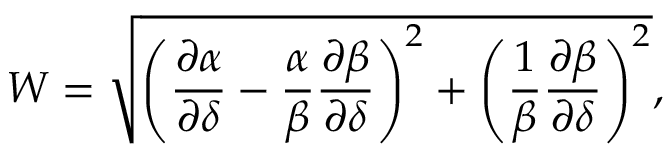<formula> <loc_0><loc_0><loc_500><loc_500>W = \sqrt { \left ( \frac { \partial \alpha } { \partial \delta } - \frac { \alpha } { \beta } \frac { \partial \beta } { \partial \delta } \right ) ^ { 2 } + \left ( \frac { 1 } { \beta } \frac { \partial \beta } { \partial \delta } \right ) ^ { 2 } } ,</formula> 